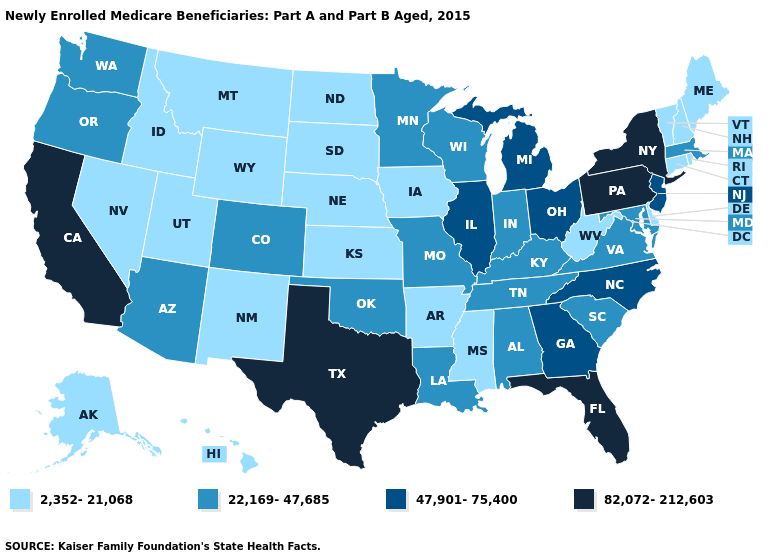Name the states that have a value in the range 82,072-212,603?
Keep it brief. California, Florida, New York, Pennsylvania, Texas. Does Colorado have the same value as Iowa?
Keep it brief. No. Which states hav the highest value in the MidWest?
Keep it brief. Illinois, Michigan, Ohio. What is the value of Iowa?
Concise answer only. 2,352-21,068. Name the states that have a value in the range 82,072-212,603?
Keep it brief. California, Florida, New York, Pennsylvania, Texas. Does the first symbol in the legend represent the smallest category?
Answer briefly. Yes. Among the states that border Arizona , does California have the highest value?
Be succinct. Yes. What is the lowest value in the USA?
Keep it brief. 2,352-21,068. Which states have the highest value in the USA?
Write a very short answer. California, Florida, New York, Pennsylvania, Texas. Name the states that have a value in the range 47,901-75,400?
Keep it brief. Georgia, Illinois, Michigan, New Jersey, North Carolina, Ohio. Name the states that have a value in the range 22,169-47,685?
Short answer required. Alabama, Arizona, Colorado, Indiana, Kentucky, Louisiana, Maryland, Massachusetts, Minnesota, Missouri, Oklahoma, Oregon, South Carolina, Tennessee, Virginia, Washington, Wisconsin. What is the value of Indiana?
Quick response, please. 22,169-47,685. What is the value of Montana?
Quick response, please. 2,352-21,068. What is the lowest value in states that border Alabama?
Concise answer only. 2,352-21,068. Which states hav the highest value in the South?
Answer briefly. Florida, Texas. 